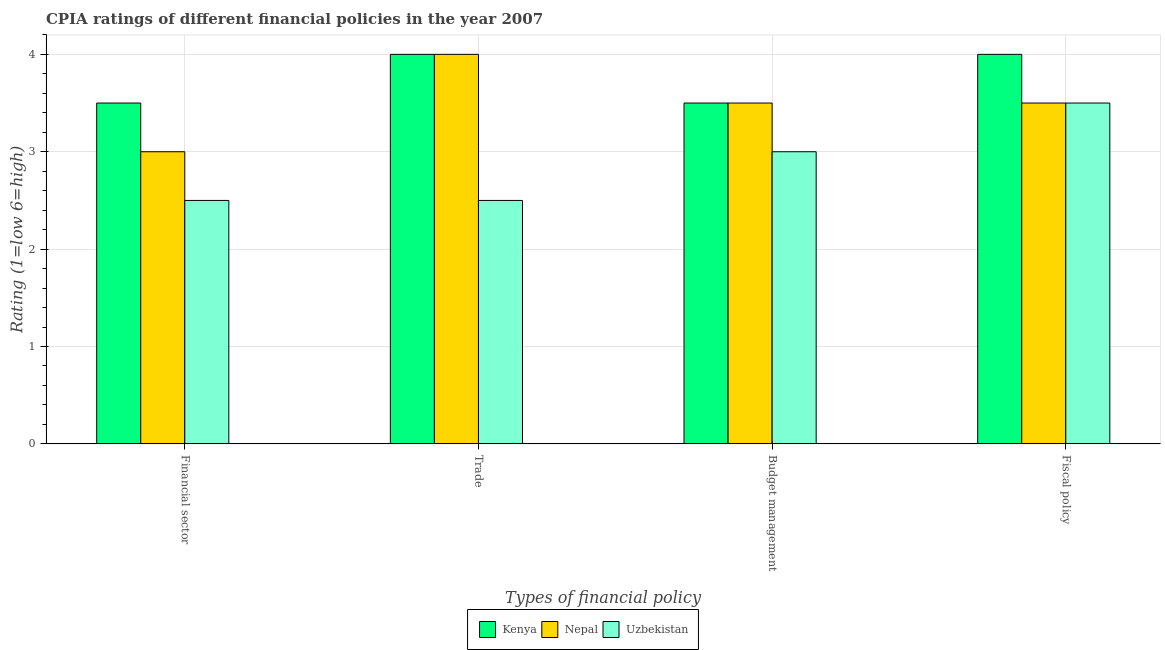How many different coloured bars are there?
Offer a terse response. 3. How many bars are there on the 3rd tick from the right?
Offer a very short reply. 3. What is the label of the 4th group of bars from the left?
Your response must be concise. Fiscal policy. What is the cpia rating of fiscal policy in Kenya?
Ensure brevity in your answer.  4. Across all countries, what is the maximum cpia rating of budget management?
Give a very brief answer. 3.5. In which country was the cpia rating of trade maximum?
Your answer should be compact. Kenya. In which country was the cpia rating of budget management minimum?
Make the answer very short. Uzbekistan. What is the total cpia rating of budget management in the graph?
Offer a terse response. 10. What is the difference between the cpia rating of financial sector in Uzbekistan and the cpia rating of budget management in Kenya?
Make the answer very short. -1. What is the average cpia rating of budget management per country?
Give a very brief answer. 3.33. In how many countries, is the cpia rating of fiscal policy greater than 3 ?
Your response must be concise. 3. What is the ratio of the cpia rating of budget management in Nepal to that in Kenya?
Your answer should be compact. 1. Is the cpia rating of financial sector in Uzbekistan less than that in Nepal?
Make the answer very short. Yes. Is the difference between the cpia rating of budget management in Uzbekistan and Nepal greater than the difference between the cpia rating of financial sector in Uzbekistan and Nepal?
Offer a terse response. No. Is the sum of the cpia rating of budget management in Kenya and Uzbekistan greater than the maximum cpia rating of fiscal policy across all countries?
Keep it short and to the point. Yes. Is it the case that in every country, the sum of the cpia rating of budget management and cpia rating of trade is greater than the sum of cpia rating of financial sector and cpia rating of fiscal policy?
Your answer should be very brief. No. What does the 1st bar from the left in Trade represents?
Give a very brief answer. Kenya. What does the 3rd bar from the right in Trade represents?
Provide a short and direct response. Kenya. How many countries are there in the graph?
Give a very brief answer. 3. Does the graph contain any zero values?
Offer a terse response. No. Does the graph contain grids?
Keep it short and to the point. Yes. Where does the legend appear in the graph?
Offer a terse response. Bottom center. How many legend labels are there?
Give a very brief answer. 3. How are the legend labels stacked?
Offer a terse response. Horizontal. What is the title of the graph?
Provide a short and direct response. CPIA ratings of different financial policies in the year 2007. What is the label or title of the X-axis?
Provide a short and direct response. Types of financial policy. What is the label or title of the Y-axis?
Your response must be concise. Rating (1=low 6=high). What is the Rating (1=low 6=high) in Nepal in Financial sector?
Give a very brief answer. 3. What is the Rating (1=low 6=high) in Uzbekistan in Financial sector?
Keep it short and to the point. 2.5. What is the Rating (1=low 6=high) in Kenya in Trade?
Make the answer very short. 4. What is the Rating (1=low 6=high) in Nepal in Trade?
Make the answer very short. 4. What is the Rating (1=low 6=high) of Uzbekistan in Budget management?
Offer a terse response. 3. What is the Rating (1=low 6=high) of Kenya in Fiscal policy?
Ensure brevity in your answer.  4. Across all Types of financial policy, what is the maximum Rating (1=low 6=high) in Kenya?
Offer a very short reply. 4. Across all Types of financial policy, what is the minimum Rating (1=low 6=high) of Kenya?
Provide a succinct answer. 3.5. What is the difference between the Rating (1=low 6=high) in Nepal in Financial sector and that in Trade?
Make the answer very short. -1. What is the difference between the Rating (1=low 6=high) in Uzbekistan in Financial sector and that in Trade?
Offer a very short reply. 0. What is the difference between the Rating (1=low 6=high) in Uzbekistan in Financial sector and that in Budget management?
Your answer should be compact. -0.5. What is the difference between the Rating (1=low 6=high) in Nepal in Financial sector and that in Fiscal policy?
Your answer should be very brief. -0.5. What is the difference between the Rating (1=low 6=high) of Uzbekistan in Financial sector and that in Fiscal policy?
Ensure brevity in your answer.  -1. What is the difference between the Rating (1=low 6=high) of Kenya in Trade and that in Budget management?
Offer a terse response. 0.5. What is the difference between the Rating (1=low 6=high) of Uzbekistan in Trade and that in Budget management?
Keep it short and to the point. -0.5. What is the difference between the Rating (1=low 6=high) of Kenya in Trade and that in Fiscal policy?
Ensure brevity in your answer.  0. What is the difference between the Rating (1=low 6=high) in Uzbekistan in Trade and that in Fiscal policy?
Offer a very short reply. -1. What is the difference between the Rating (1=low 6=high) in Uzbekistan in Budget management and that in Fiscal policy?
Keep it short and to the point. -0.5. What is the difference between the Rating (1=low 6=high) in Nepal in Financial sector and the Rating (1=low 6=high) in Uzbekistan in Trade?
Offer a very short reply. 0.5. What is the difference between the Rating (1=low 6=high) in Nepal in Financial sector and the Rating (1=low 6=high) in Uzbekistan in Budget management?
Make the answer very short. 0. What is the difference between the Rating (1=low 6=high) in Kenya in Financial sector and the Rating (1=low 6=high) in Nepal in Fiscal policy?
Your answer should be compact. 0. What is the difference between the Rating (1=low 6=high) of Kenya in Financial sector and the Rating (1=low 6=high) of Uzbekistan in Fiscal policy?
Ensure brevity in your answer.  0. What is the difference between the Rating (1=low 6=high) of Kenya in Trade and the Rating (1=low 6=high) of Nepal in Budget management?
Offer a very short reply. 0.5. What is the difference between the Rating (1=low 6=high) of Kenya in Trade and the Rating (1=low 6=high) of Uzbekistan in Budget management?
Offer a terse response. 1. What is the difference between the Rating (1=low 6=high) in Nepal in Trade and the Rating (1=low 6=high) in Uzbekistan in Budget management?
Give a very brief answer. 1. What is the difference between the Rating (1=low 6=high) in Kenya in Trade and the Rating (1=low 6=high) in Nepal in Fiscal policy?
Offer a terse response. 0.5. What is the difference between the Rating (1=low 6=high) of Kenya in Trade and the Rating (1=low 6=high) of Uzbekistan in Fiscal policy?
Provide a short and direct response. 0.5. What is the average Rating (1=low 6=high) of Kenya per Types of financial policy?
Provide a succinct answer. 3.75. What is the average Rating (1=low 6=high) in Nepal per Types of financial policy?
Keep it short and to the point. 3.5. What is the average Rating (1=low 6=high) in Uzbekistan per Types of financial policy?
Offer a terse response. 2.88. What is the difference between the Rating (1=low 6=high) of Kenya and Rating (1=low 6=high) of Nepal in Financial sector?
Provide a short and direct response. 0.5. What is the difference between the Rating (1=low 6=high) of Nepal and Rating (1=low 6=high) of Uzbekistan in Financial sector?
Offer a very short reply. 0.5. What is the difference between the Rating (1=low 6=high) in Nepal and Rating (1=low 6=high) in Uzbekistan in Trade?
Ensure brevity in your answer.  1.5. What is the difference between the Rating (1=low 6=high) in Kenya and Rating (1=low 6=high) in Nepal in Budget management?
Make the answer very short. 0. What is the difference between the Rating (1=low 6=high) in Kenya and Rating (1=low 6=high) in Nepal in Fiscal policy?
Give a very brief answer. 0.5. What is the difference between the Rating (1=low 6=high) in Kenya and Rating (1=low 6=high) in Uzbekistan in Fiscal policy?
Provide a short and direct response. 0.5. What is the ratio of the Rating (1=low 6=high) in Kenya in Financial sector to that in Trade?
Your answer should be very brief. 0.88. What is the ratio of the Rating (1=low 6=high) of Nepal in Financial sector to that in Trade?
Offer a very short reply. 0.75. What is the ratio of the Rating (1=low 6=high) of Kenya in Financial sector to that in Budget management?
Make the answer very short. 1. What is the ratio of the Rating (1=low 6=high) in Nepal in Financial sector to that in Budget management?
Your response must be concise. 0.86. What is the ratio of the Rating (1=low 6=high) of Kenya in Financial sector to that in Fiscal policy?
Keep it short and to the point. 0.88. What is the ratio of the Rating (1=low 6=high) of Nepal in Financial sector to that in Fiscal policy?
Provide a short and direct response. 0.86. What is the ratio of the Rating (1=low 6=high) in Uzbekistan in Financial sector to that in Fiscal policy?
Your answer should be compact. 0.71. What is the ratio of the Rating (1=low 6=high) of Uzbekistan in Trade to that in Budget management?
Make the answer very short. 0.83. What is the ratio of the Rating (1=low 6=high) of Nepal in Trade to that in Fiscal policy?
Offer a very short reply. 1.14. What is the ratio of the Rating (1=low 6=high) in Kenya in Budget management to that in Fiscal policy?
Your answer should be compact. 0.88. What is the ratio of the Rating (1=low 6=high) of Nepal in Budget management to that in Fiscal policy?
Offer a terse response. 1. What is the ratio of the Rating (1=low 6=high) in Uzbekistan in Budget management to that in Fiscal policy?
Your response must be concise. 0.86. What is the difference between the highest and the second highest Rating (1=low 6=high) of Nepal?
Your response must be concise. 0.5. What is the difference between the highest and the lowest Rating (1=low 6=high) in Kenya?
Offer a very short reply. 0.5. What is the difference between the highest and the lowest Rating (1=low 6=high) in Nepal?
Provide a short and direct response. 1. 